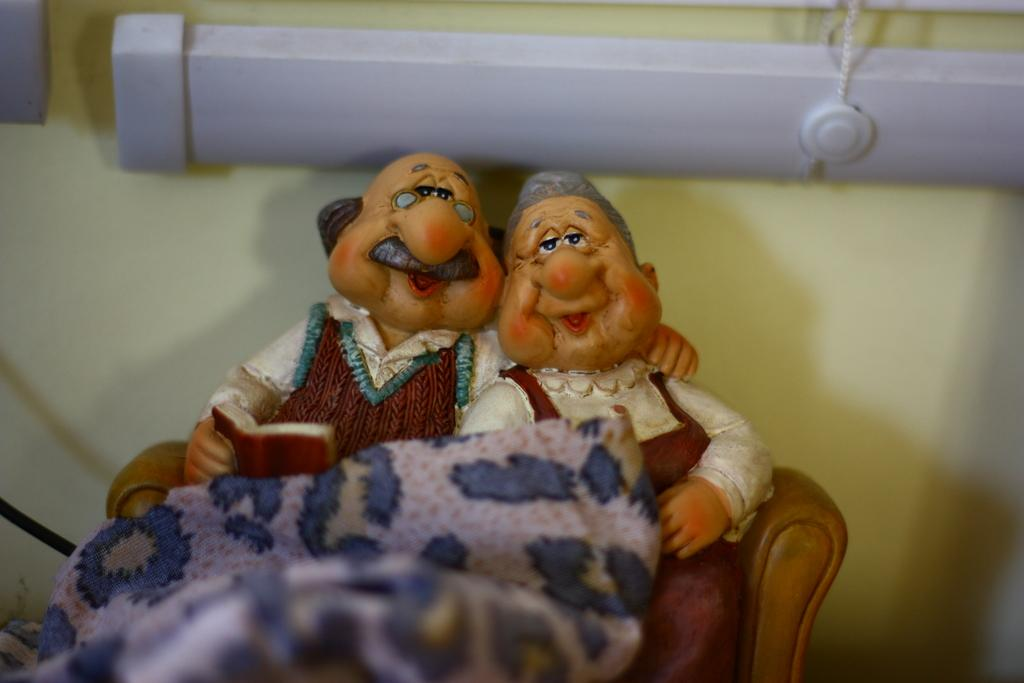What type of objects can be seen in the image? There are toys in the image. What else is present in the image besides the toys? There is a cloth in the image. Can you describe the white object at the top of the image? There is a white object at the top of the image, but its specific nature is not clear from the facts provided. What is attached to the white object at the top of the image? There is a thread at the top of the image. What type of texture can be seen on the school building in the image? There is no school building present in the image, so it is not possible to determine the texture of any such structure. 